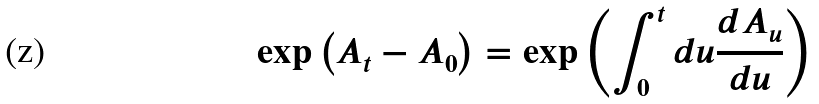Convert formula to latex. <formula><loc_0><loc_0><loc_500><loc_500>\exp \left ( A _ { t } - A _ { 0 } \right ) = \exp \left ( \int _ { 0 } ^ { t } d u \frac { d A _ { u } } { d u } \right )</formula> 